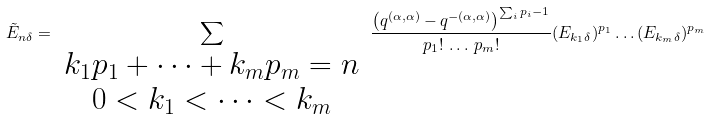<formula> <loc_0><loc_0><loc_500><loc_500>\tilde { E } _ { n \delta } = \sum _ { \begin{array} { c } k _ { 1 } p _ { 1 } + \dots + k _ { m } p _ { m } = n \\ 0 < k _ { 1 } < \dots < k _ { m } \end{array} } \frac { \left ( q ^ { ( \alpha , \alpha ) } - q ^ { - ( \alpha , \alpha ) } \right ) ^ { \sum _ { i } p _ { i } - 1 } } { p _ { 1 } ! \, \dots \, p _ { m } ! } ( E _ { k _ { 1 } \delta } ) ^ { p _ { 1 } } \dots ( E _ { k _ { m } \delta } ) ^ { p _ { m } }</formula> 